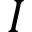<formula> <loc_0><loc_0><loc_500><loc_500>I</formula> 